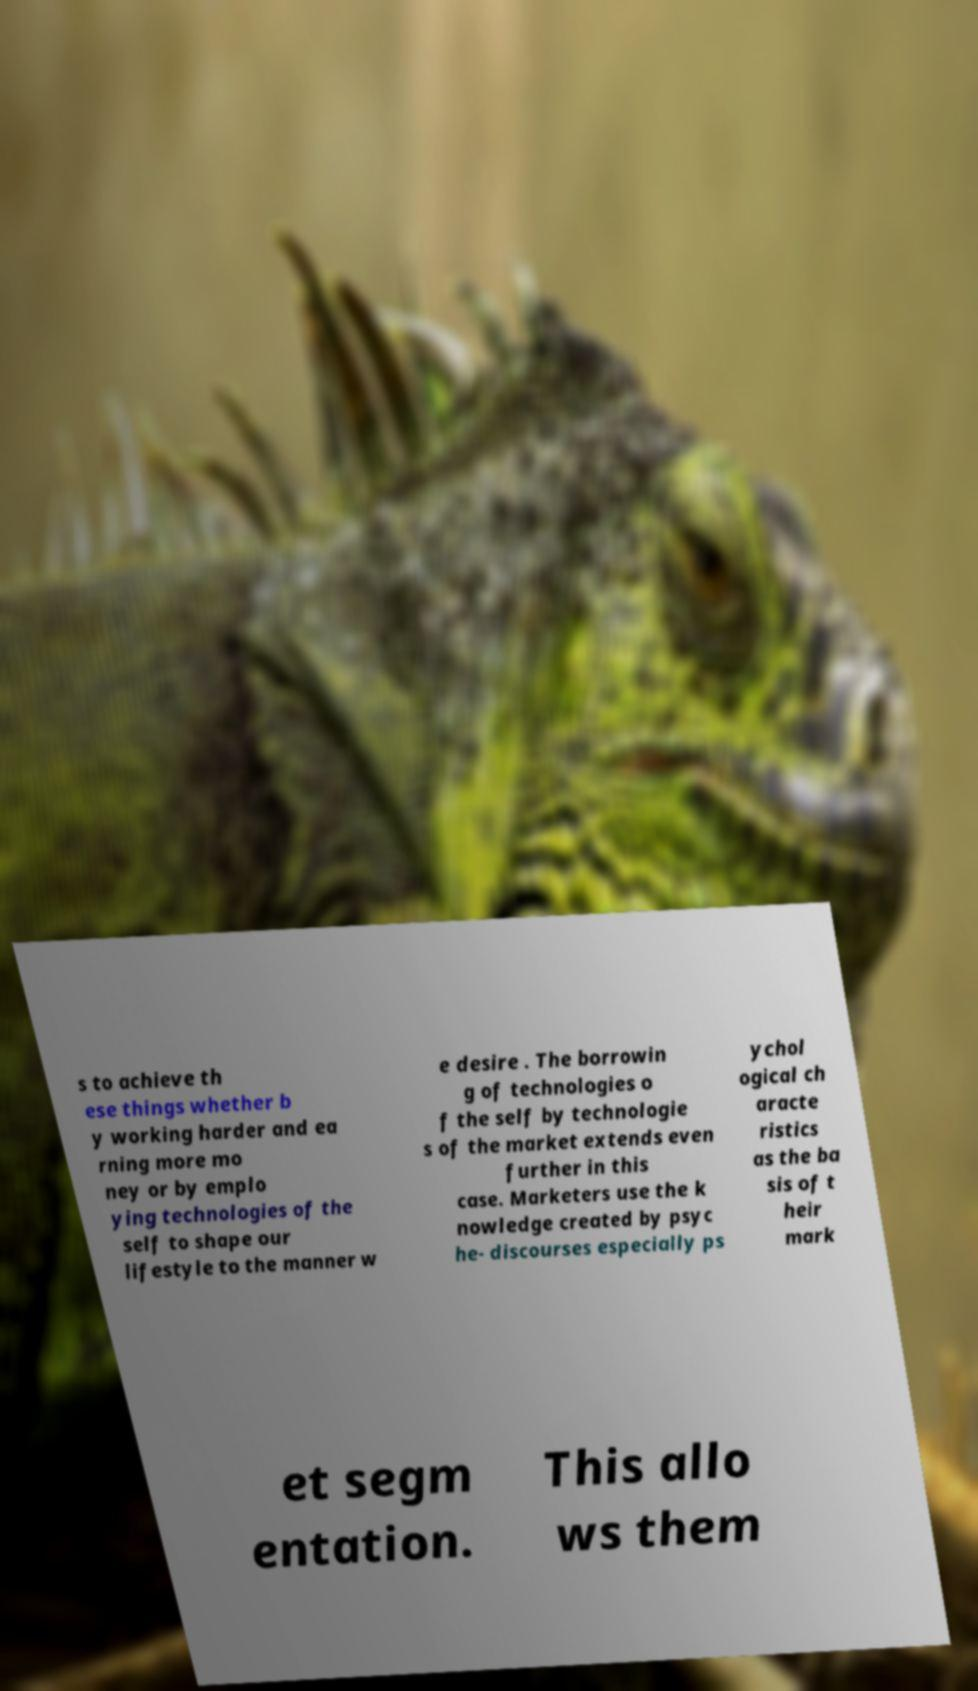Please read and relay the text visible in this image. What does it say? s to achieve th ese things whether b y working harder and ea rning more mo ney or by emplo ying technologies of the self to shape our lifestyle to the manner w e desire . The borrowin g of technologies o f the self by technologie s of the market extends even further in this case. Marketers use the k nowledge created by psyc he- discourses especially ps ychol ogical ch aracte ristics as the ba sis of t heir mark et segm entation. This allo ws them 